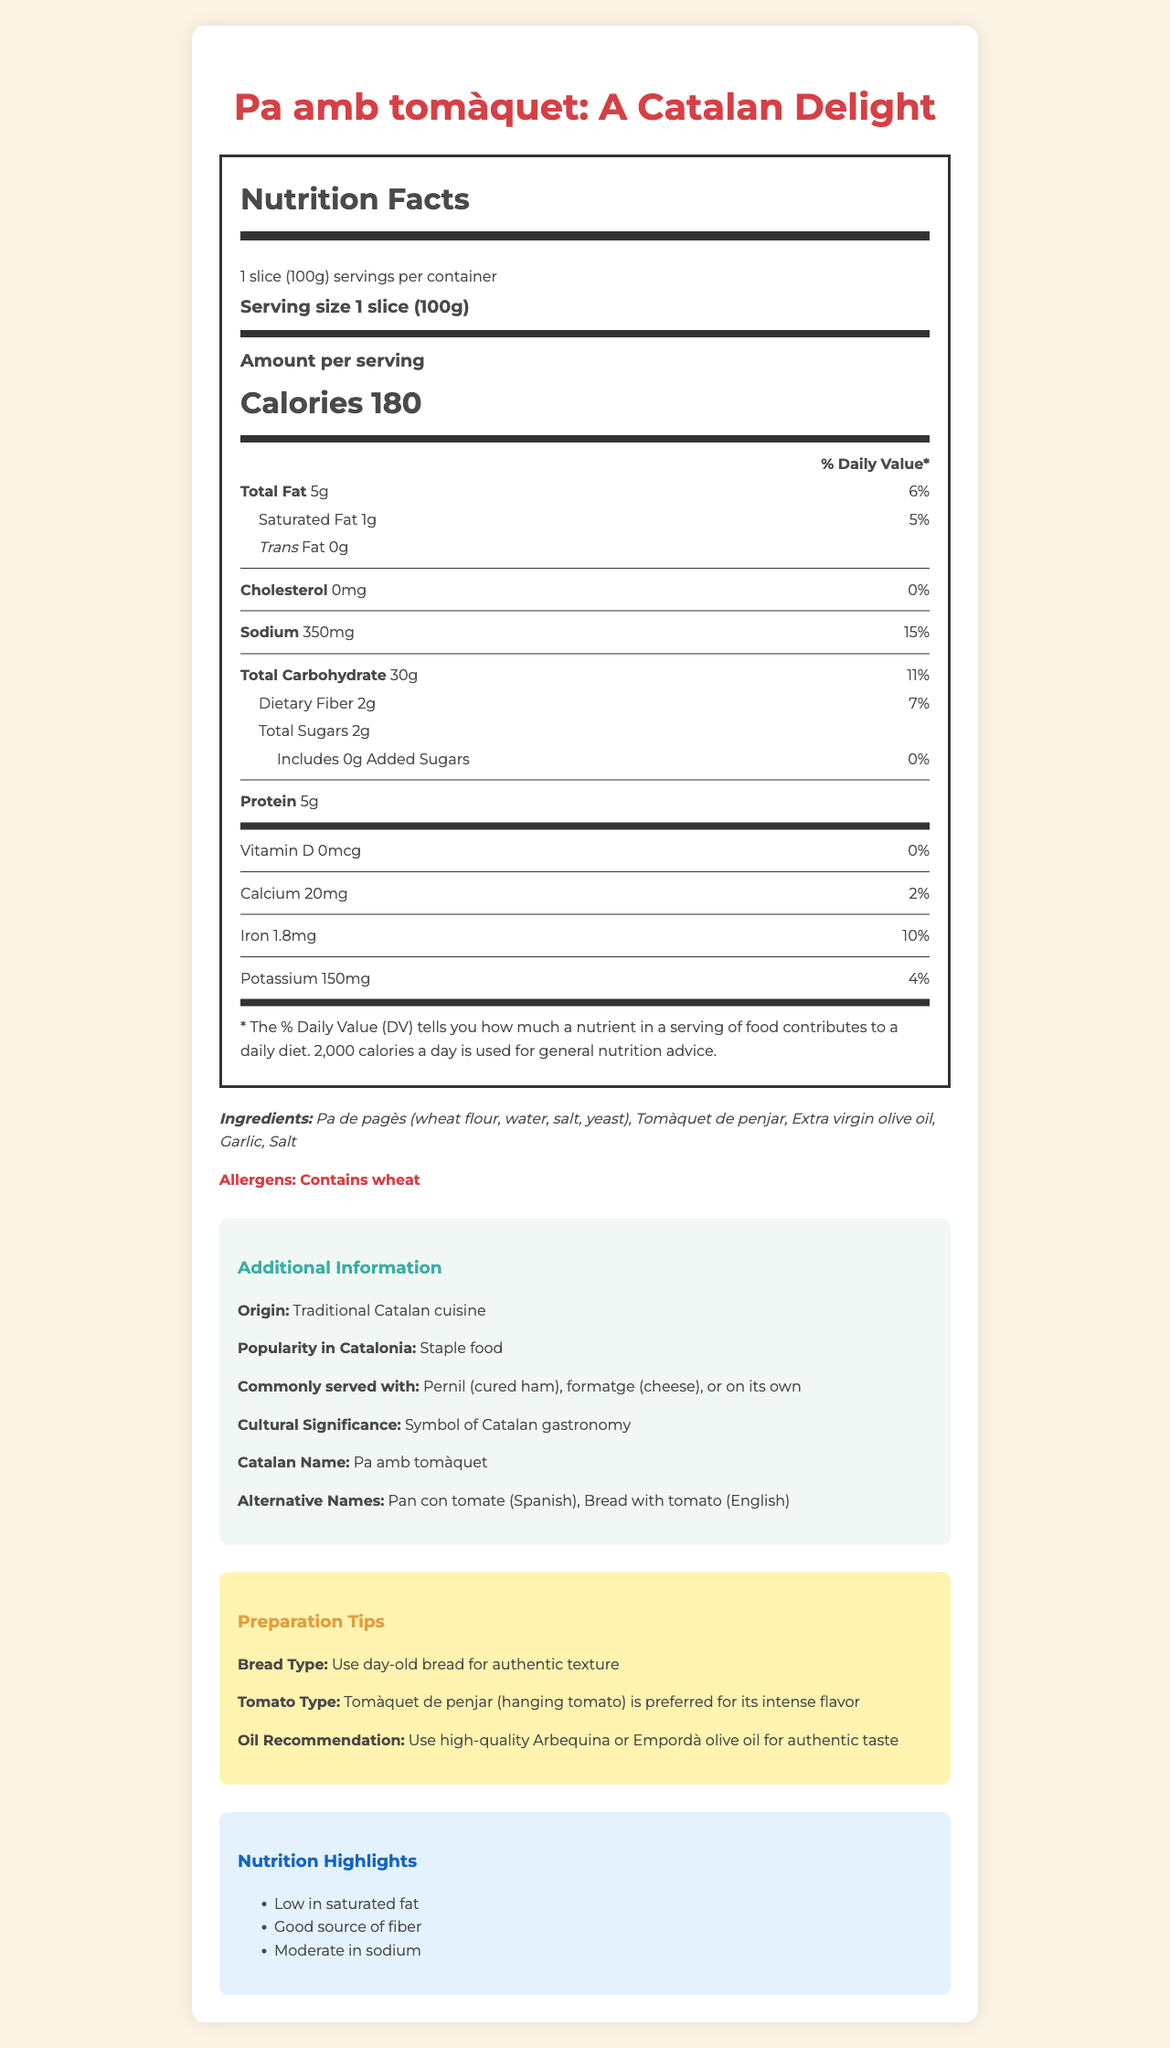what is the serving size? The document states that the serving size for pa amb tomàquet is 1 slice (100g).
Answer: 1 slice (100g) how many calories are in one serving? The document lists the calories per serving as 180.
Answer: 180 what is the total fat content per serving? The document shows that the total fat content per serving is 5g.
Answer: 5g what percentage of the daily value for sodium does one serving provide? According to the document, one serving provides 15% of the daily value for sodium.
Answer: 15% how much protein is in one serving? The document indicates that one serving contains 5g of protein.
Answer: 5g what ingredient is specifically mentioned as containing wheat? The ingredients list includes "Pa de pagès," which contains wheat flour.
Answer: Pa de pagès what is the daily value percentage for calcium per serving? A. 1% B. 2% C. 5% D. 10% The document states that the daily value percentage for calcium per serving is 2%.
Answer: B which type of bread is recommended for authentic texture? A. Fresh bread B. Day-old bread C. Toasted bread D. Sourdough bread The preparation tips recommend using day-old bread for an authentic texture.
Answer: B does the nutrition label include any added sugars? The document indicates that added sugars are 0g, meaning there are no added sugars.
Answer: No is pa amb tomàquet a staple food in Catalonia? The document notes that pa amb tomàquet is a staple food in Catalonia.
Answer: Yes how many servings are in one container? The document specifies that there is 1 serving per container.
Answer: 1 what is the main idea of the document? The document comprehensively covers various aspects of pa amb tomàquet, from its nutritional content to its cultural importance and preparation recommendations.
Answer: The document provides detailed nutrition facts and additional information about traditional Catalan pa amb tomàquet, including ingredients, cultural significance, preparation tips, and nutrition highlights. does the document state the origin of pa amb tomàquet? The document states that the origin is "Traditional Catalan cuisine."
Answer: Yes what is the recommended type of tomato for making pa amb tomàquet? The preparation tips recommend using Tomàquet de penjar for its intense flavor.
Answer: Tomàquet de penjar who is the intended audience for this document? The document does not specify the intended audience, and thus we cannot determine this from the visual information provided.
Answer: Not enough information 